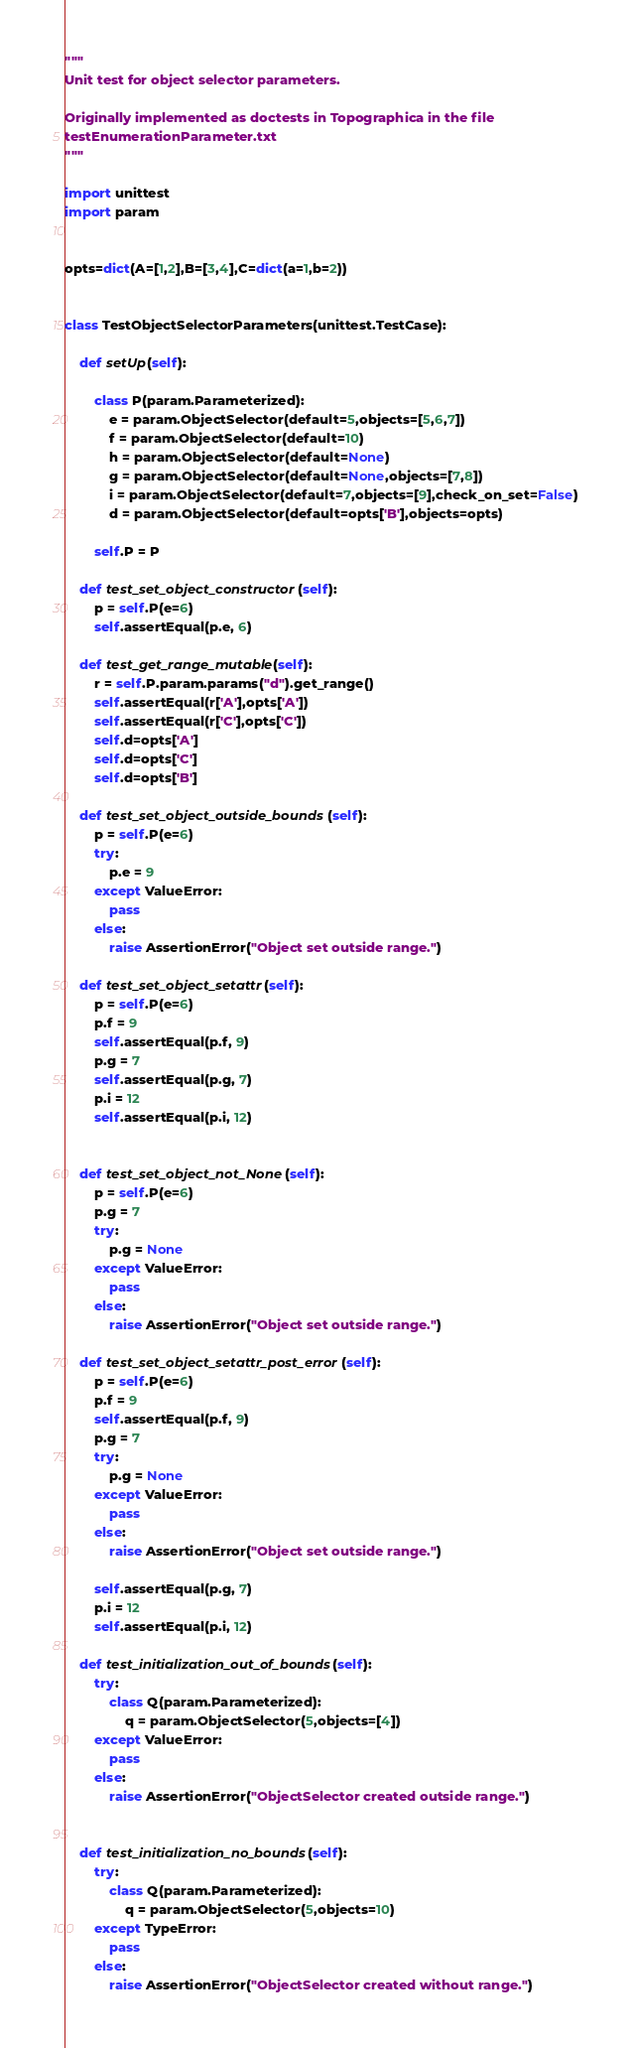<code> <loc_0><loc_0><loc_500><loc_500><_Python_>"""
Unit test for object selector parameters.

Originally implemented as doctests in Topographica in the file
testEnumerationParameter.txt
"""

import unittest
import param


opts=dict(A=[1,2],B=[3,4],C=dict(a=1,b=2))


class TestObjectSelectorParameters(unittest.TestCase):

    def setUp(self):

        class P(param.Parameterized):
            e = param.ObjectSelector(default=5,objects=[5,6,7])
            f = param.ObjectSelector(default=10)
            h = param.ObjectSelector(default=None)
            g = param.ObjectSelector(default=None,objects=[7,8])
            i = param.ObjectSelector(default=7,objects=[9],check_on_set=False)
            d = param.ObjectSelector(default=opts['B'],objects=opts)
            
        self.P = P

    def test_set_object_constructor(self):
        p = self.P(e=6)
        self.assertEqual(p.e, 6)

    def test_get_range_mutable(self):
        r = self.P.param.params("d").get_range()
        self.assertEqual(r['A'],opts['A'])
        self.assertEqual(r['C'],opts['C'])
        self.d=opts['A']
        self.d=opts['C']
        self.d=opts['B']

    def test_set_object_outside_bounds(self):
        p = self.P(e=6)
        try:
            p.e = 9
        except ValueError:
            pass
        else:
            raise AssertionError("Object set outside range.")

    def test_set_object_setattr(self):
        p = self.P(e=6)
        p.f = 9
        self.assertEqual(p.f, 9)
        p.g = 7
        self.assertEqual(p.g, 7)
        p.i = 12
        self.assertEqual(p.i, 12)


    def test_set_object_not_None(self):
        p = self.P(e=6)
        p.g = 7
        try:
            p.g = None
        except ValueError:
            pass
        else:
            raise AssertionError("Object set outside range.")

    def test_set_object_setattr_post_error(self):
        p = self.P(e=6)
        p.f = 9
        self.assertEqual(p.f, 9)
        p.g = 7
        try:
            p.g = None
        except ValueError:
            pass
        else:
            raise AssertionError("Object set outside range.")

        self.assertEqual(p.g, 7)
        p.i = 12
        self.assertEqual(p.i, 12)

    def test_initialization_out_of_bounds(self):
        try:
            class Q(param.Parameterized):
                q = param.ObjectSelector(5,objects=[4])
        except ValueError:
            pass
        else:
            raise AssertionError("ObjectSelector created outside range.")


    def test_initialization_no_bounds(self):
        try:
            class Q(param.Parameterized):
                q = param.ObjectSelector(5,objects=10)
        except TypeError:
            pass
        else:
            raise AssertionError("ObjectSelector created without range.")
</code> 